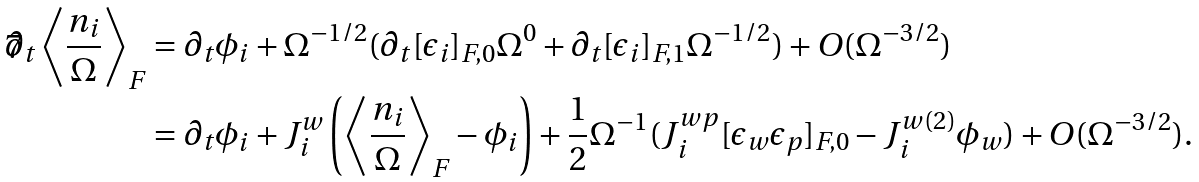Convert formula to latex. <formula><loc_0><loc_0><loc_500><loc_500>\partial _ { t } \left \langle \frac { n _ { i } } { \Omega } \right \rangle _ { F } & = \partial _ { t } \phi _ { i } + \Omega ^ { - 1 / 2 } ( \partial _ { t } [ \epsilon _ { i } ] _ { F , 0 } \Omega ^ { 0 } + \partial _ { t } [ \epsilon _ { i } ] _ { F , 1 } \Omega ^ { - 1 / 2 } ) + O ( \Omega ^ { - 3 / 2 } ) \\ & = \partial _ { t } \phi _ { i } + J _ { i } ^ { w } \left ( \left \langle \frac { n _ { i } } { \Omega } \right \rangle _ { F } - \phi _ { i } \right ) + \frac { 1 } { 2 } \Omega ^ { - 1 } ( J _ { i } ^ { w p } [ \epsilon _ { w } \epsilon _ { p } ] _ { F , 0 } - J _ { i } ^ { w ( 2 ) } \phi _ { w } ) + O ( \Omega ^ { - 3 / 2 } ) .</formula> 